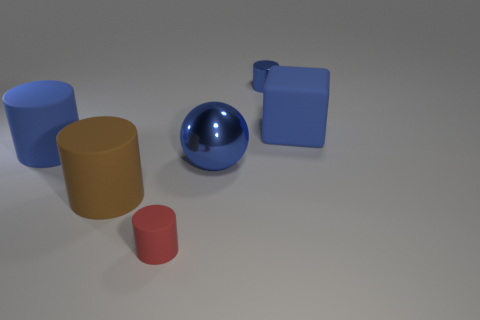Add 2 large metallic balls. How many objects exist? 8 Subtract all cubes. How many objects are left? 5 Add 4 red things. How many red things are left? 5 Add 6 tiny red matte cylinders. How many tiny red matte cylinders exist? 7 Subtract 1 blue balls. How many objects are left? 5 Subtract all brown objects. Subtract all small blue shiny cylinders. How many objects are left? 4 